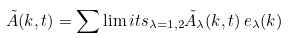<formula> <loc_0><loc_0><loc_500><loc_500>\tilde { A } ( { k } , t ) = \sum \lim i t s _ { \lambda = 1 , 2 } { \tilde { A } _ { \lambda } } ( { k } , t ) \, { e } _ { \lambda } ( { k } )</formula> 